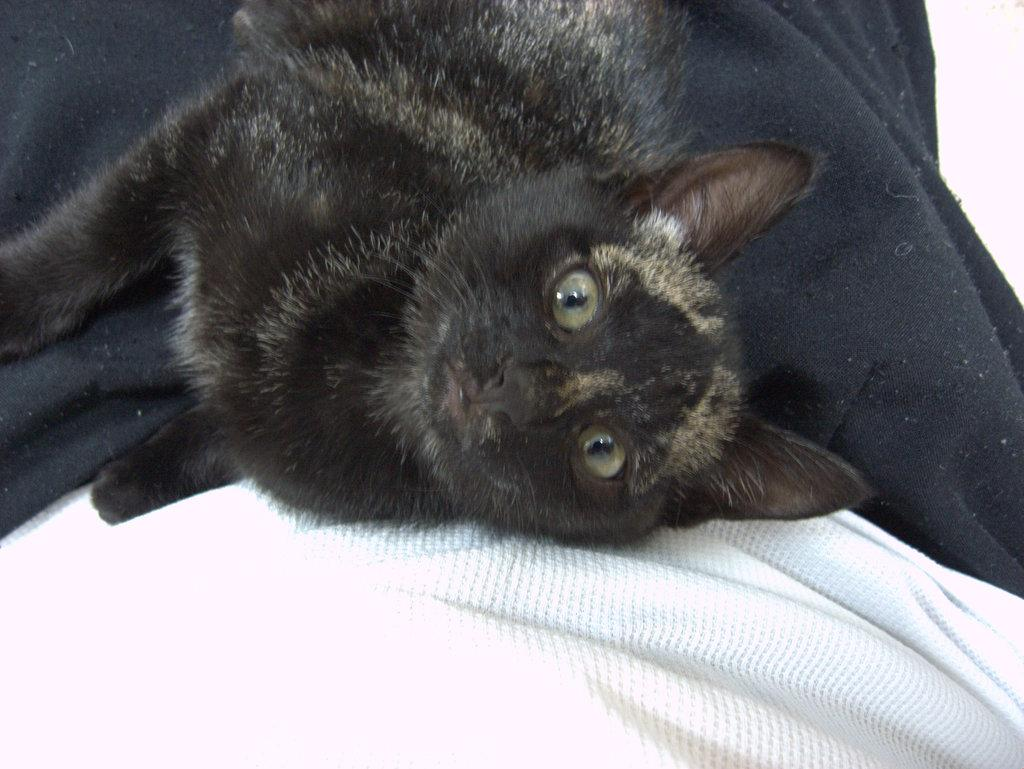What type of animal is present in the image? There is a cat in the image. What is the cat lying on? The cat is lying on a cloth. Can you describe the color of the cloth at the bottom of the image? There is a white cloth at the bottom of the image. What is the color of the cloth at the top of the image? There is a black cloth at the top of the image. How many pies are being kicked by the cat in the image? There are no pies or kicking activity present in the image. What type of wind can be seen blowing the cat in the image? There is no wind or blowing activity present in the image; the cat is lying on a cloth. 